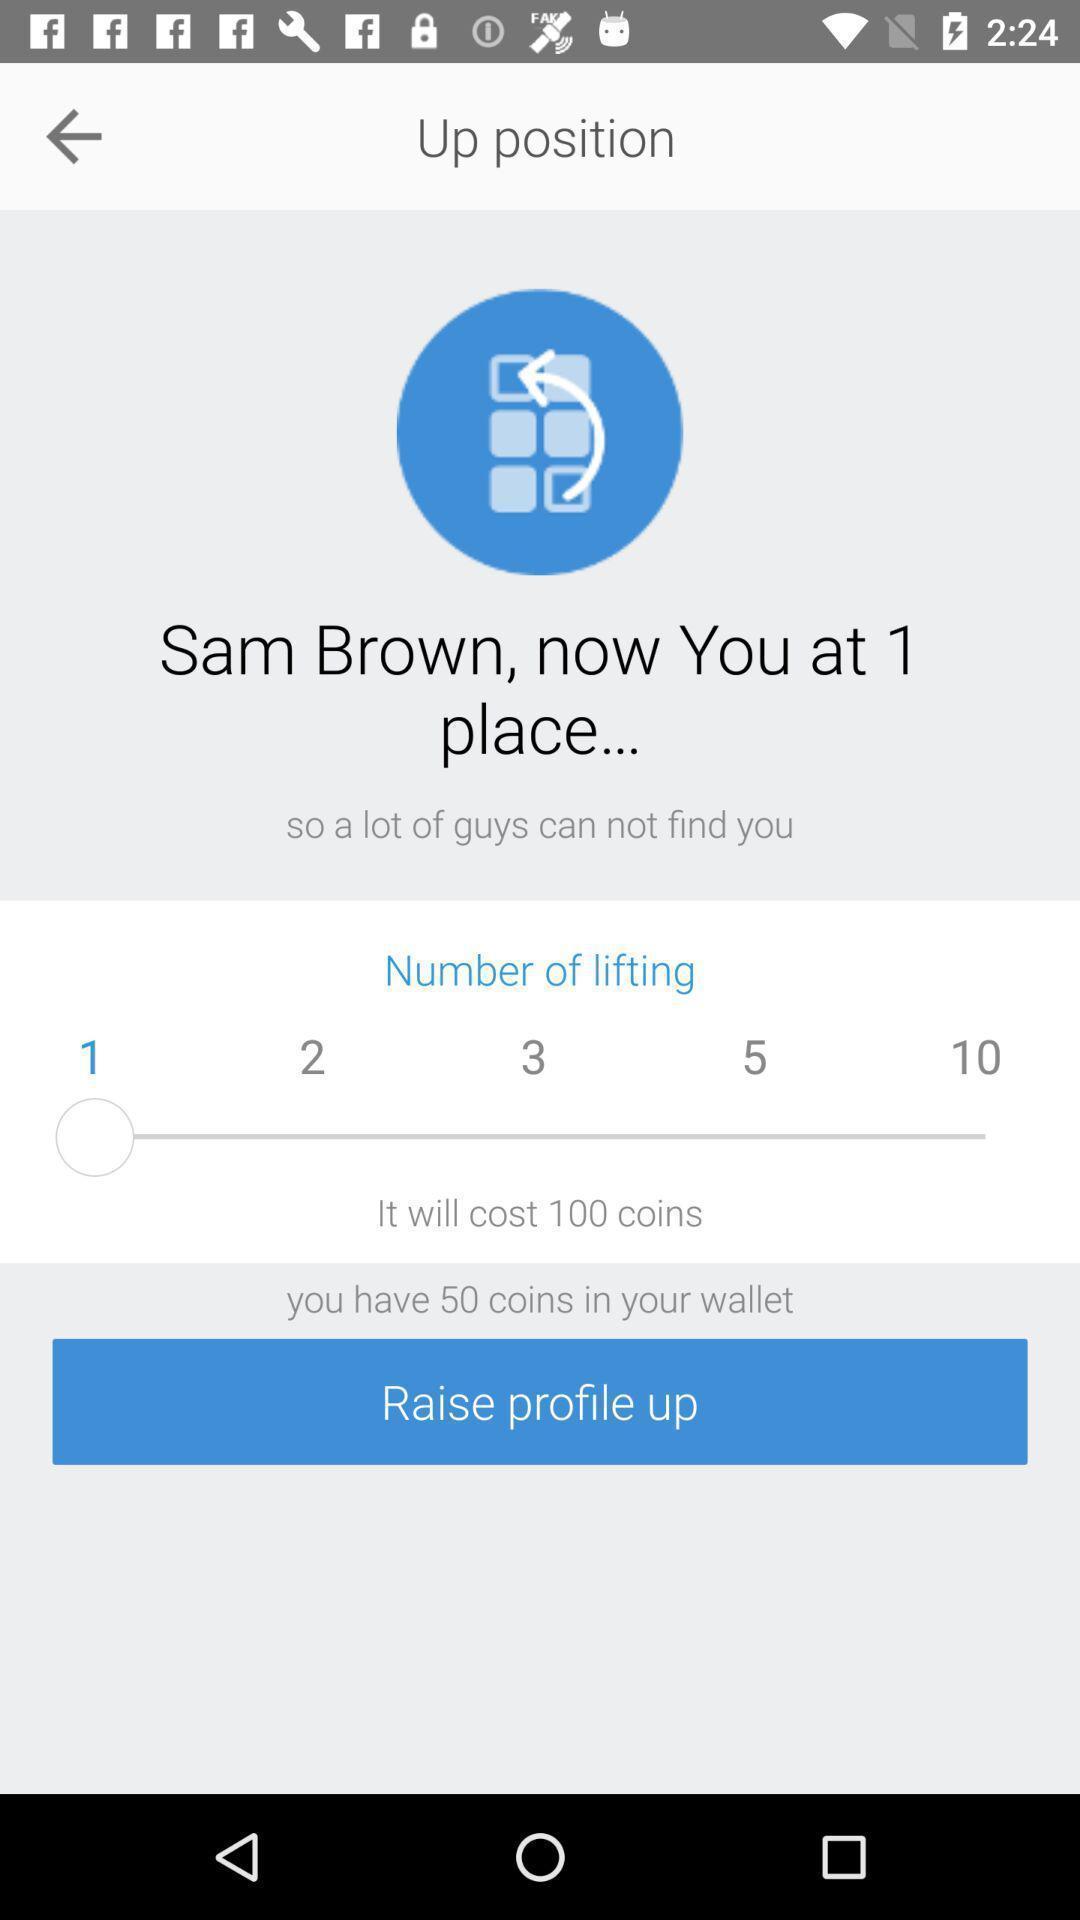What is the overall content of this screenshot? Screen displaying to raise a profile. 